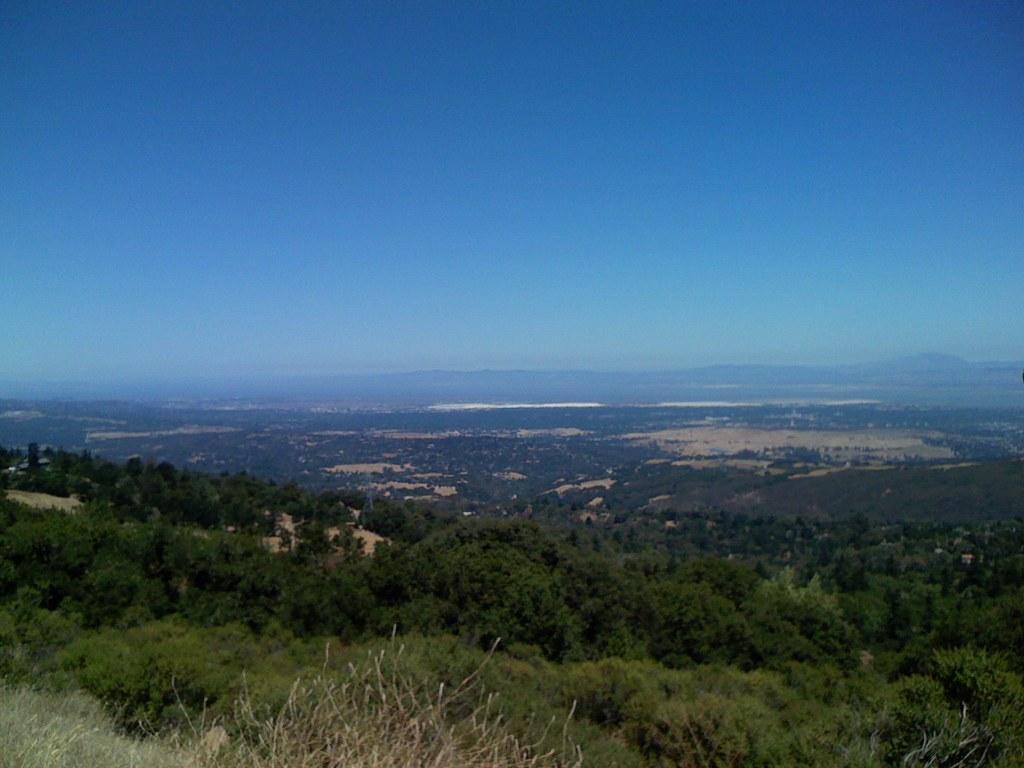In one or two sentences, can you explain what this image depicts? In this image we can see some trees and in the background, we can see the mountains and at the top we can see the sky. 